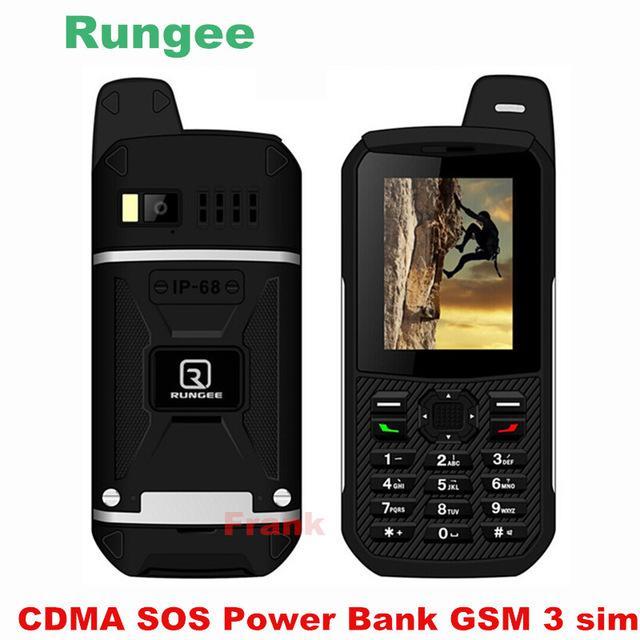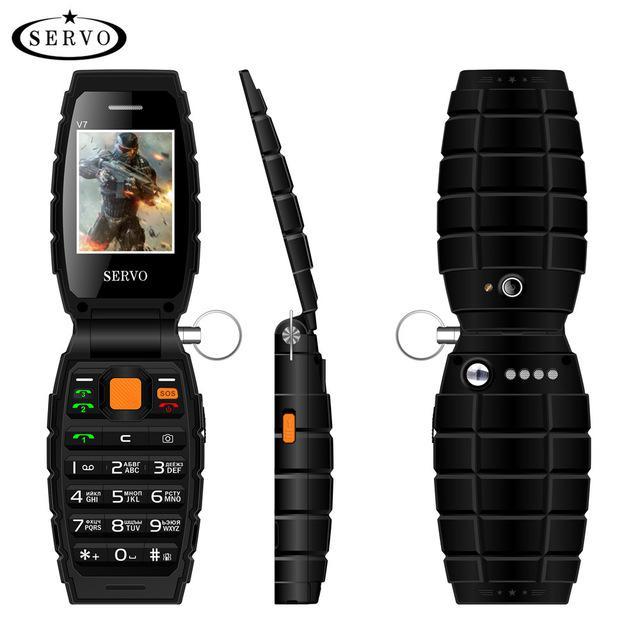The first image is the image on the left, the second image is the image on the right. Evaluate the accuracy of this statement regarding the images: "One of the images shows the side profile of a phone.". Is it true? Answer yes or no. Yes. The first image is the image on the left, the second image is the image on the right. Examine the images to the left and right. Is the description "Ninety or fewer physical buttons are visible." accurate? Answer yes or no. Yes. 